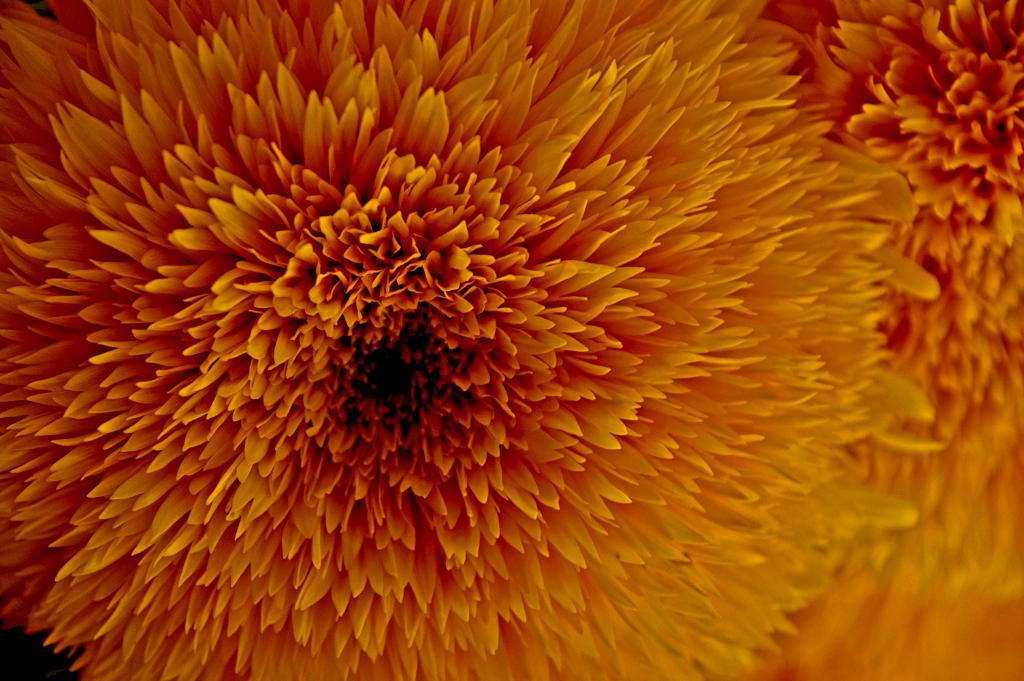What is the main subject of the image? There is a flower in the center of the image. What are the main features of the flower? The flower has petals. What type of animal can be seen making a request in the image? There is no animal present in the image, nor is there any indication of a request being made. 